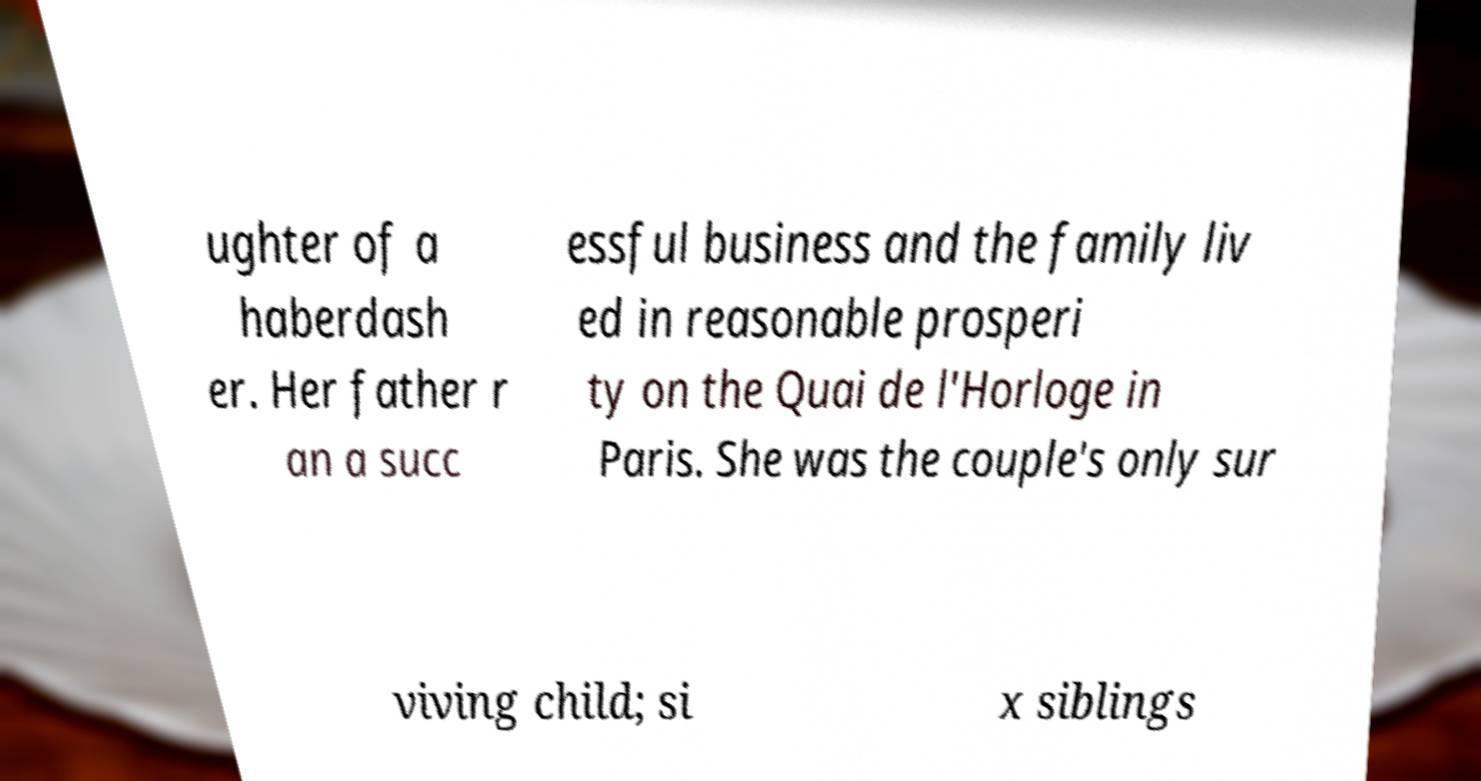There's text embedded in this image that I need extracted. Can you transcribe it verbatim? ughter of a haberdash er. Her father r an a succ essful business and the family liv ed in reasonable prosperi ty on the Quai de l'Horloge in Paris. She was the couple's only sur viving child; si x siblings 